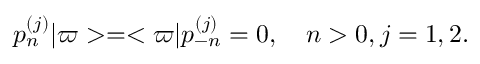Convert formula to latex. <formula><loc_0><loc_0><loc_500><loc_500>p _ { n } ^ { ( j ) } | \varpi > = < \varpi | p _ { - n } ^ { ( j ) } = 0 , \quad n > 0 , j = 1 , 2 .</formula> 